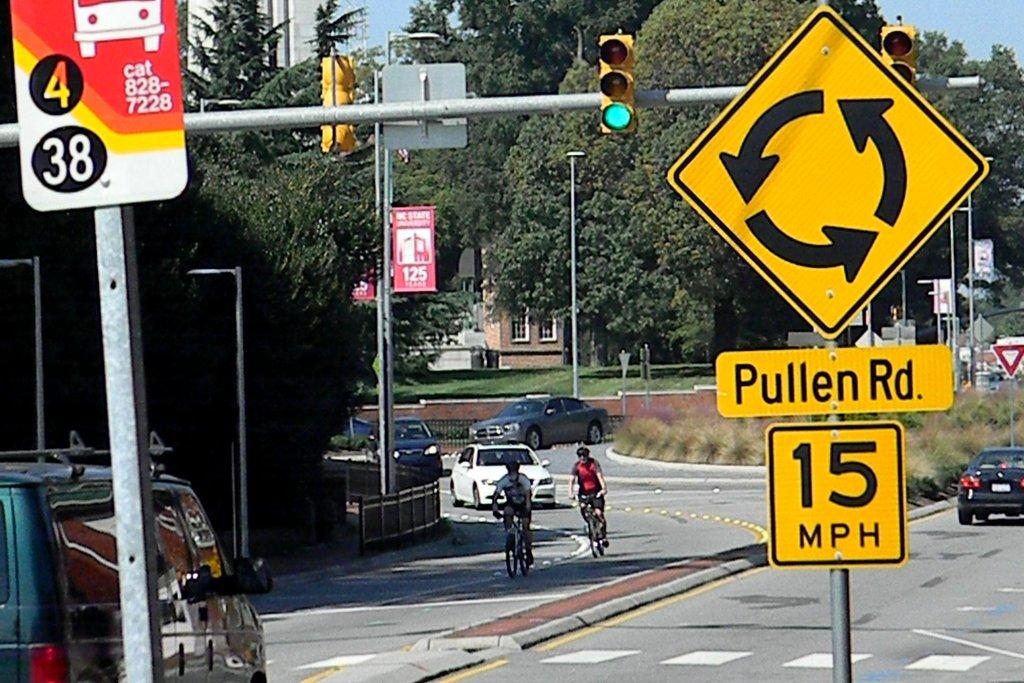What is the speed limit?
Provide a short and direct response. 15 mph. What is the speed limit?
Provide a succinct answer. 15 mph. 